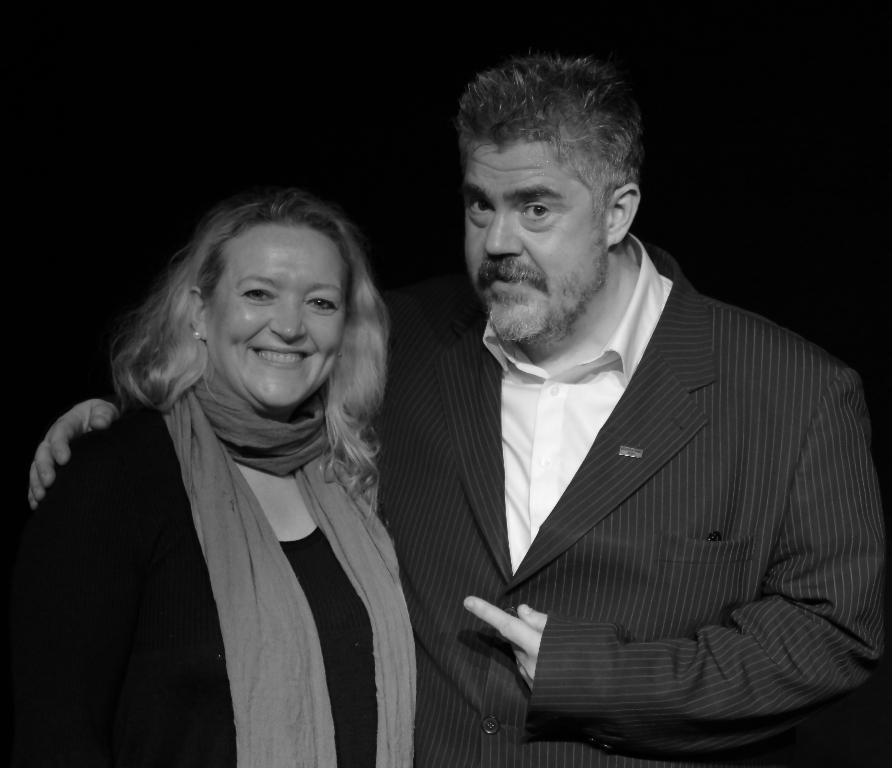How many people are in the image? There are two people in the image. What are the people wearing? Both people are wearing dresses. What is the color scheme of the image? The image is black and white. How much steam is visible in the image? There is no steam present in the image, as it is a black and white image of two people wearing dresses. 